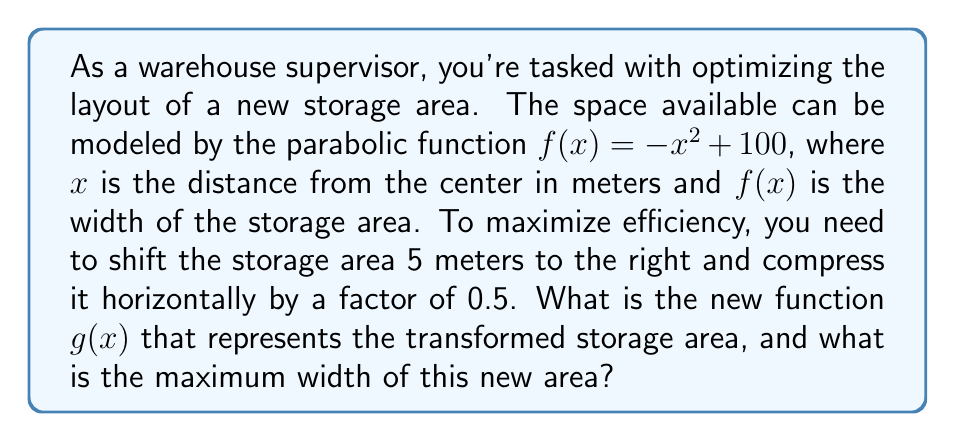Can you solve this math problem? Let's approach this step-by-step:

1) The original function is $f(x) = -x^2 + 100$

2) We need to apply two transformations:
   a) Shift 5 meters to the right: Replace $x$ with $(x - 5)$
   b) Compress horizontally by a factor of 0.5: Replace $x$ with $(2x)$

3) Combining these transformations, we replace $x$ with $2(x - 5)$:

   $g(x) = -(2(x - 5))^2 + 100$

4) Let's simplify this:
   $g(x) = -(4x^2 - 40x + 100) + 100$
   $g(x) = -4x^2 + 40x - 100 + 100$
   $g(x) = -4x^2 + 40x$

5) To find the maximum width, we need to find the vertex of this parabola.
   For a parabola in the form $ax^2 + bx + c$, the x-coordinate of the vertex is given by $-b/(2a)$

6) In our case, $a = -4$ and $b = 40$
   $x = -40 / (2(-4)) = 40/8 = 5$

7) To find the maximum width, we substitute $x = 5$ into our function:
   $g(5) = -4(5)^2 + 40(5) = -100 + 200 = 100$

Therefore, the maximum width of the new storage area is 100 meters.
Answer: $g(x) = -4x^2 + 40x$; Maximum width: 100 meters 